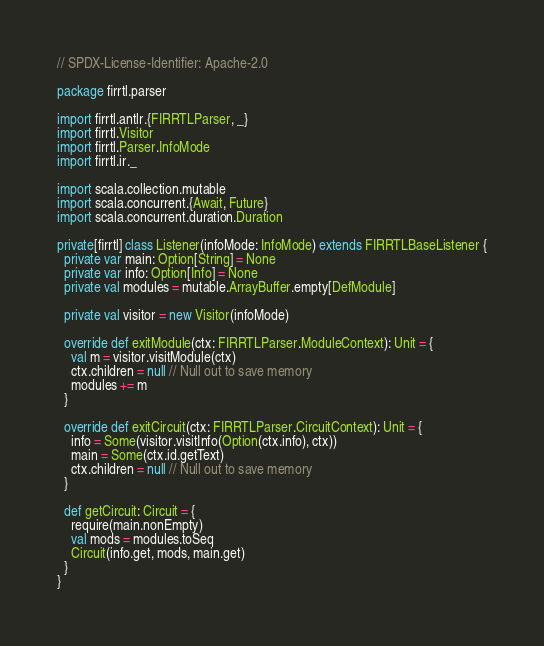Convert code to text. <code><loc_0><loc_0><loc_500><loc_500><_Scala_>// SPDX-License-Identifier: Apache-2.0

package firrtl.parser

import firrtl.antlr.{FIRRTLParser, _}
import firrtl.Visitor
import firrtl.Parser.InfoMode
import firrtl.ir._

import scala.collection.mutable
import scala.concurrent.{Await, Future}
import scala.concurrent.duration.Duration

private[firrtl] class Listener(infoMode: InfoMode) extends FIRRTLBaseListener {
  private var main: Option[String] = None
  private var info: Option[Info] = None
  private val modules = mutable.ArrayBuffer.empty[DefModule]

  private val visitor = new Visitor(infoMode)

  override def exitModule(ctx: FIRRTLParser.ModuleContext): Unit = {
    val m = visitor.visitModule(ctx)
    ctx.children = null // Null out to save memory
    modules += m
  }

  override def exitCircuit(ctx: FIRRTLParser.CircuitContext): Unit = {
    info = Some(visitor.visitInfo(Option(ctx.info), ctx))
    main = Some(ctx.id.getText)
    ctx.children = null // Null out to save memory
  }

  def getCircuit: Circuit = {
    require(main.nonEmpty)
    val mods = modules.toSeq
    Circuit(info.get, mods, main.get)
  }
}
</code> 